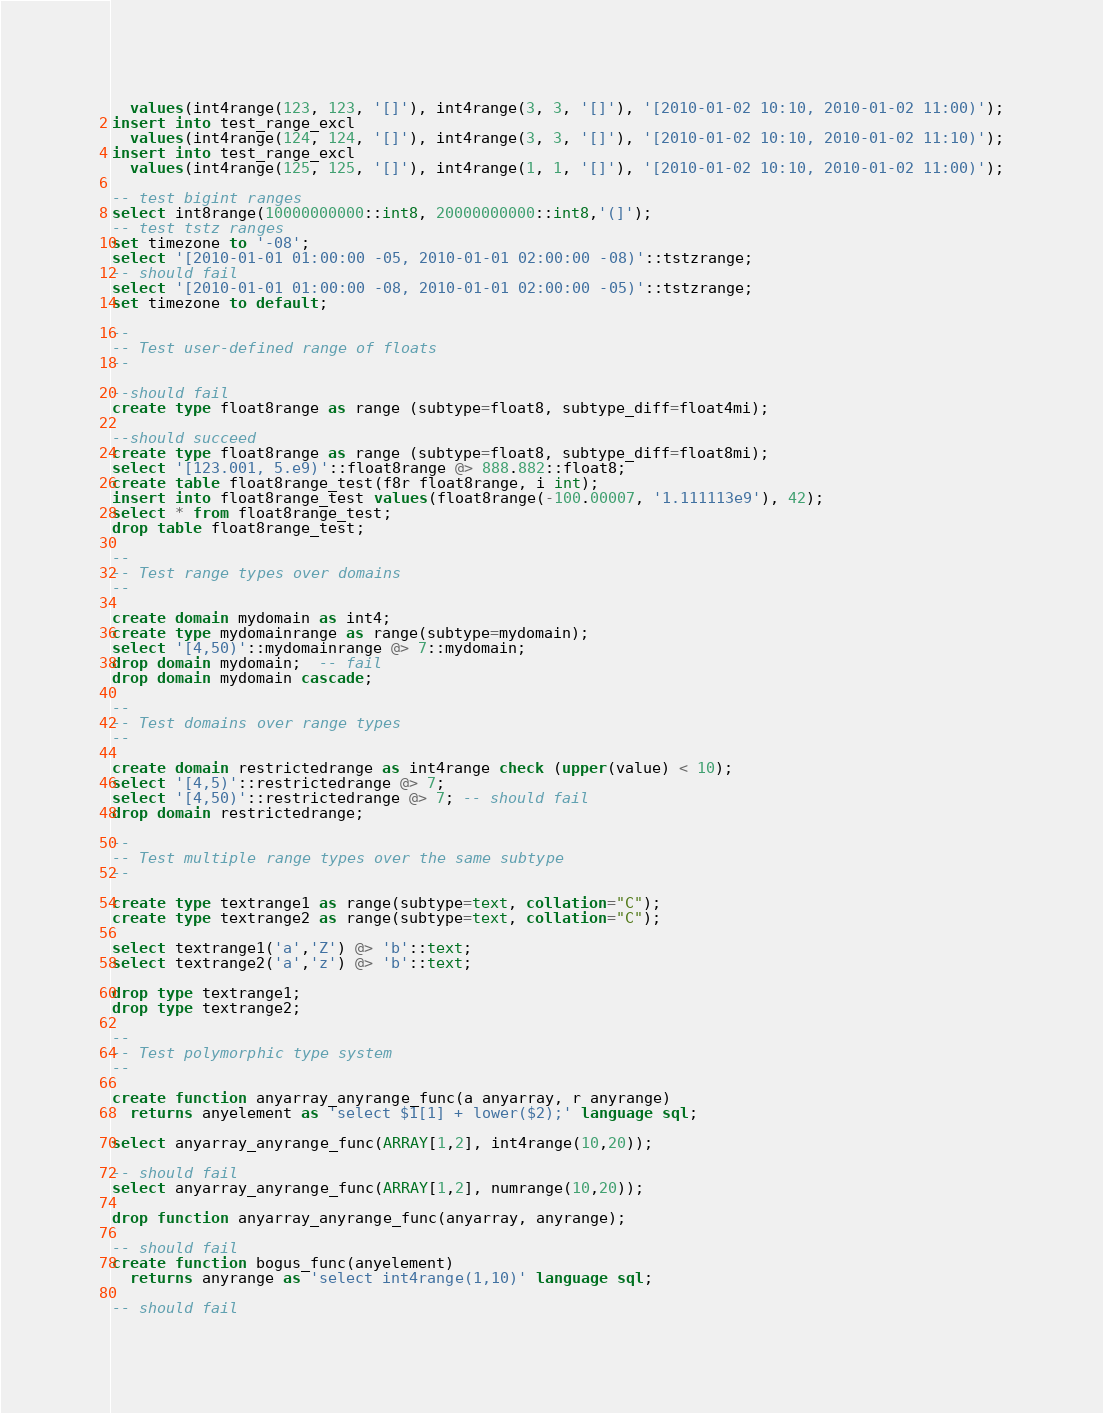<code> <loc_0><loc_0><loc_500><loc_500><_SQL_>  values(int4range(123, 123, '[]'), int4range(3, 3, '[]'), '[2010-01-02 10:10, 2010-01-02 11:00)');
insert into test_range_excl
  values(int4range(124, 124, '[]'), int4range(3, 3, '[]'), '[2010-01-02 10:10, 2010-01-02 11:10)');
insert into test_range_excl
  values(int4range(125, 125, '[]'), int4range(1, 1, '[]'), '[2010-01-02 10:10, 2010-01-02 11:00)');

-- test bigint ranges
select int8range(10000000000::int8, 20000000000::int8,'(]');
-- test tstz ranges
set timezone to '-08';
select '[2010-01-01 01:00:00 -05, 2010-01-01 02:00:00 -08)'::tstzrange;
-- should fail
select '[2010-01-01 01:00:00 -08, 2010-01-01 02:00:00 -05)'::tstzrange;
set timezone to default;

--
-- Test user-defined range of floats
--

--should fail
create type float8range as range (subtype=float8, subtype_diff=float4mi);

--should succeed
create type float8range as range (subtype=float8, subtype_diff=float8mi);
select '[123.001, 5.e9)'::float8range @> 888.882::float8;
create table float8range_test(f8r float8range, i int);
insert into float8range_test values(float8range(-100.00007, '1.111113e9'), 42);
select * from float8range_test;
drop table float8range_test;

--
-- Test range types over domains
--

create domain mydomain as int4;
create type mydomainrange as range(subtype=mydomain);
select '[4,50)'::mydomainrange @> 7::mydomain;
drop domain mydomain;  -- fail
drop domain mydomain cascade;

--
-- Test domains over range types
--

create domain restrictedrange as int4range check (upper(value) < 10);
select '[4,5)'::restrictedrange @> 7;
select '[4,50)'::restrictedrange @> 7; -- should fail
drop domain restrictedrange;

--
-- Test multiple range types over the same subtype
--

create type textrange1 as range(subtype=text, collation="C");
create type textrange2 as range(subtype=text, collation="C");

select textrange1('a','Z') @> 'b'::text;
select textrange2('a','z') @> 'b'::text;

drop type textrange1;
drop type textrange2;

--
-- Test polymorphic type system
--

create function anyarray_anyrange_func(a anyarray, r anyrange)
  returns anyelement as 'select $1[1] + lower($2);' language sql;

select anyarray_anyrange_func(ARRAY[1,2], int4range(10,20));

-- should fail
select anyarray_anyrange_func(ARRAY[1,2], numrange(10,20));

drop function anyarray_anyrange_func(anyarray, anyrange);

-- should fail
create function bogus_func(anyelement)
  returns anyrange as 'select int4range(1,10)' language sql;

-- should fail</code> 